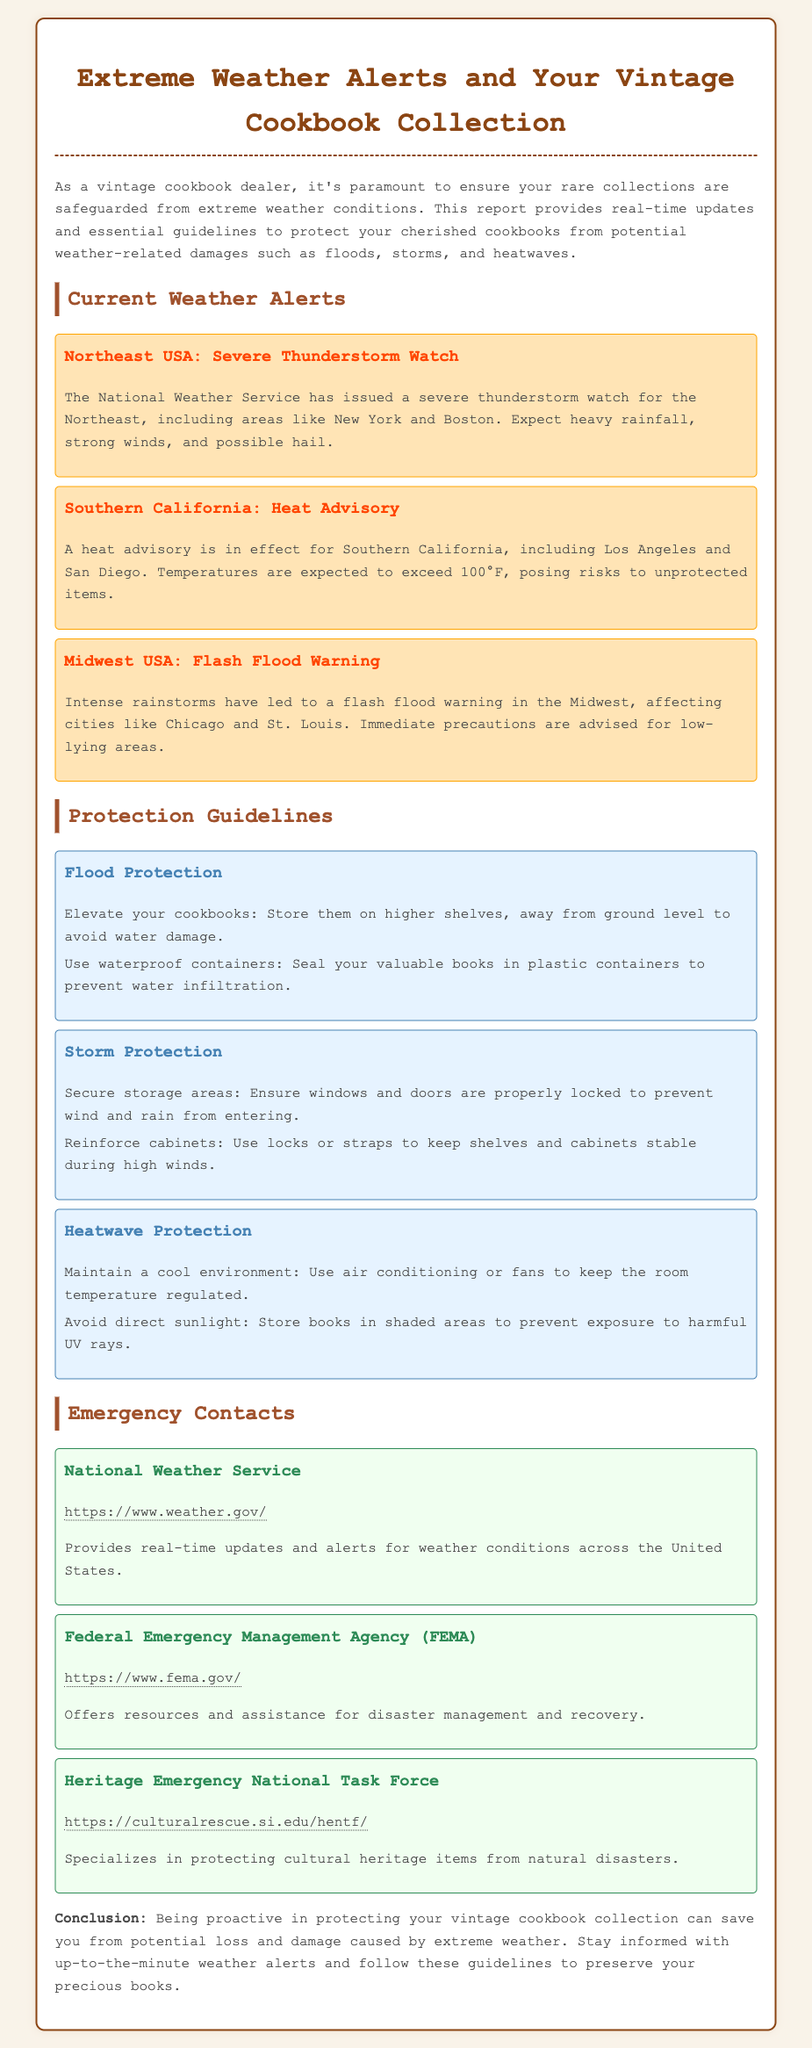What weather alert is issued for the Northeast USA? The document states that a severe thunderstorm watch has been issued for the Northeast.
Answer: Severe Thunderstorm Watch What is the temperature expected during the heat advisory in Southern California? The document mentions that temperatures are expected to exceed 100°F.
Answer: Exceed 100°F Which city is affected by the flash flood warning in the Midwest? The document specifically mentions Chicago as one of the cities affected by the flash flood warning.
Answer: Chicago What is one guideline to protect cookbooks from floods? One guideline from the document is to store cookbooks on higher shelves.
Answer: Elevate your cookbooks What should you do to protect your cookbooks from heatwaves? The document advises to maintain a cool environment for your cookbooks during heatwaves.
Answer: Maintain a cool environment Which organization provides real-time weather updates? The document lists the National Weather Service as providing real-time updates and alerts.
Answer: National Weather Service How many types of weather alerts are mentioned in the report? The document outlines three types of alerts: severe thunderstorm, heat advisory, and flash flood warning.
Answer: Three What is a recommended action to take before a storm? The document recommends securing storage areas as a precaution before a storm.
Answer: Secure storage areas Which federal agency offers resources for disaster management? The Federal Emergency Management Agency (FEMA) is mentioned in the document.
Answer: FEMA 